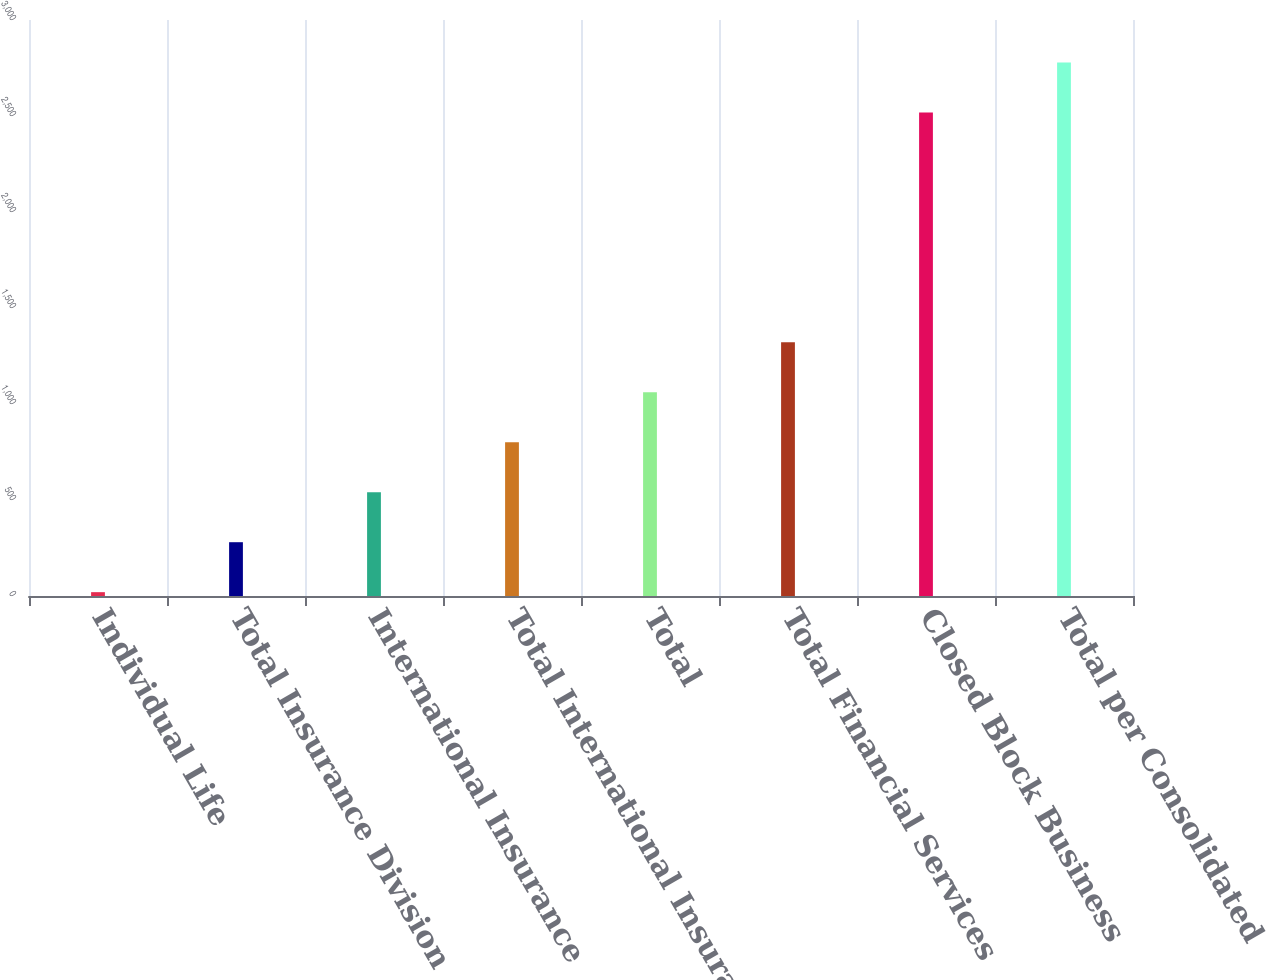Convert chart to OTSL. <chart><loc_0><loc_0><loc_500><loc_500><bar_chart><fcel>Individual Life<fcel>Total Insurance Division<fcel>International Insurance<fcel>Total International Insurance<fcel>Total<fcel>Total Financial Services<fcel>Closed Block Business<fcel>Total per Consolidated<nl><fcel>20<fcel>280.2<fcel>540.4<fcel>800.6<fcel>1060.8<fcel>1321<fcel>2518<fcel>2778.2<nl></chart> 